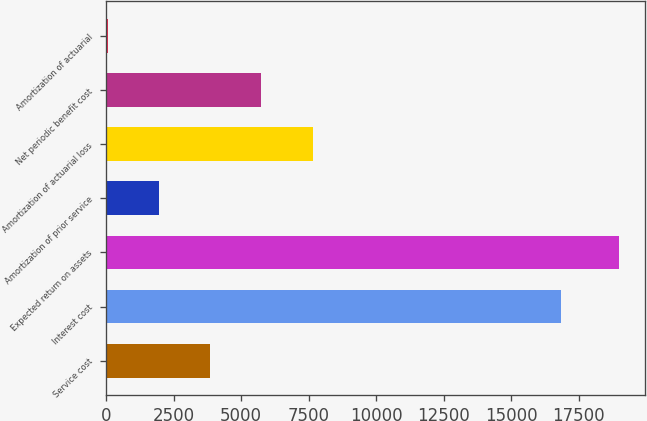Convert chart. <chart><loc_0><loc_0><loc_500><loc_500><bar_chart><fcel>Service cost<fcel>Interest cost<fcel>Expected return on assets<fcel>Amortization of prior service<fcel>Amortization of actuarial loss<fcel>Net periodic benefit cost<fcel>Amortization of actuarial<nl><fcel>3856<fcel>16852<fcel>19012<fcel>1961.5<fcel>7645<fcel>5750.5<fcel>67<nl></chart> 